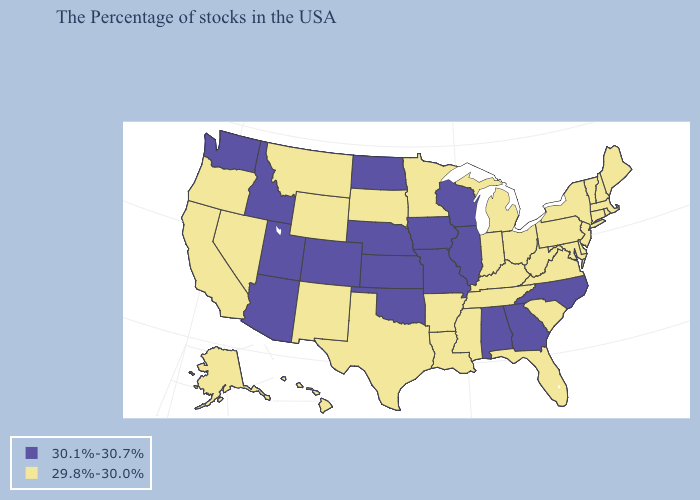Name the states that have a value in the range 30.1%-30.7%?
Keep it brief. North Carolina, Georgia, Alabama, Wisconsin, Illinois, Missouri, Iowa, Kansas, Nebraska, Oklahoma, North Dakota, Colorado, Utah, Arizona, Idaho, Washington. Is the legend a continuous bar?
Quick response, please. No. Among the states that border Oregon , which have the highest value?
Quick response, please. Idaho, Washington. Among the states that border Utah , does Wyoming have the lowest value?
Write a very short answer. Yes. What is the lowest value in the West?
Answer briefly. 29.8%-30.0%. Among the states that border Nebraska , which have the lowest value?
Short answer required. South Dakota, Wyoming. What is the value of Colorado?
Quick response, please. 30.1%-30.7%. What is the lowest value in states that border Nebraska?
Quick response, please. 29.8%-30.0%. Among the states that border Iowa , does Nebraska have the lowest value?
Answer briefly. No. What is the lowest value in states that border Oregon?
Keep it brief. 29.8%-30.0%. Among the states that border Tennessee , which have the highest value?
Keep it brief. North Carolina, Georgia, Alabama, Missouri. What is the value of Virginia?
Be succinct. 29.8%-30.0%. What is the highest value in the USA?
Quick response, please. 30.1%-30.7%. 